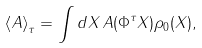Convert formula to latex. <formula><loc_0><loc_0><loc_500><loc_500>\left < A \right > _ { \tau } = \int d X \, A ( \Phi ^ { \tau } X ) \rho _ { 0 } ( X ) ,</formula> 